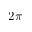Convert formula to latex. <formula><loc_0><loc_0><loc_500><loc_500>2 \pi</formula> 